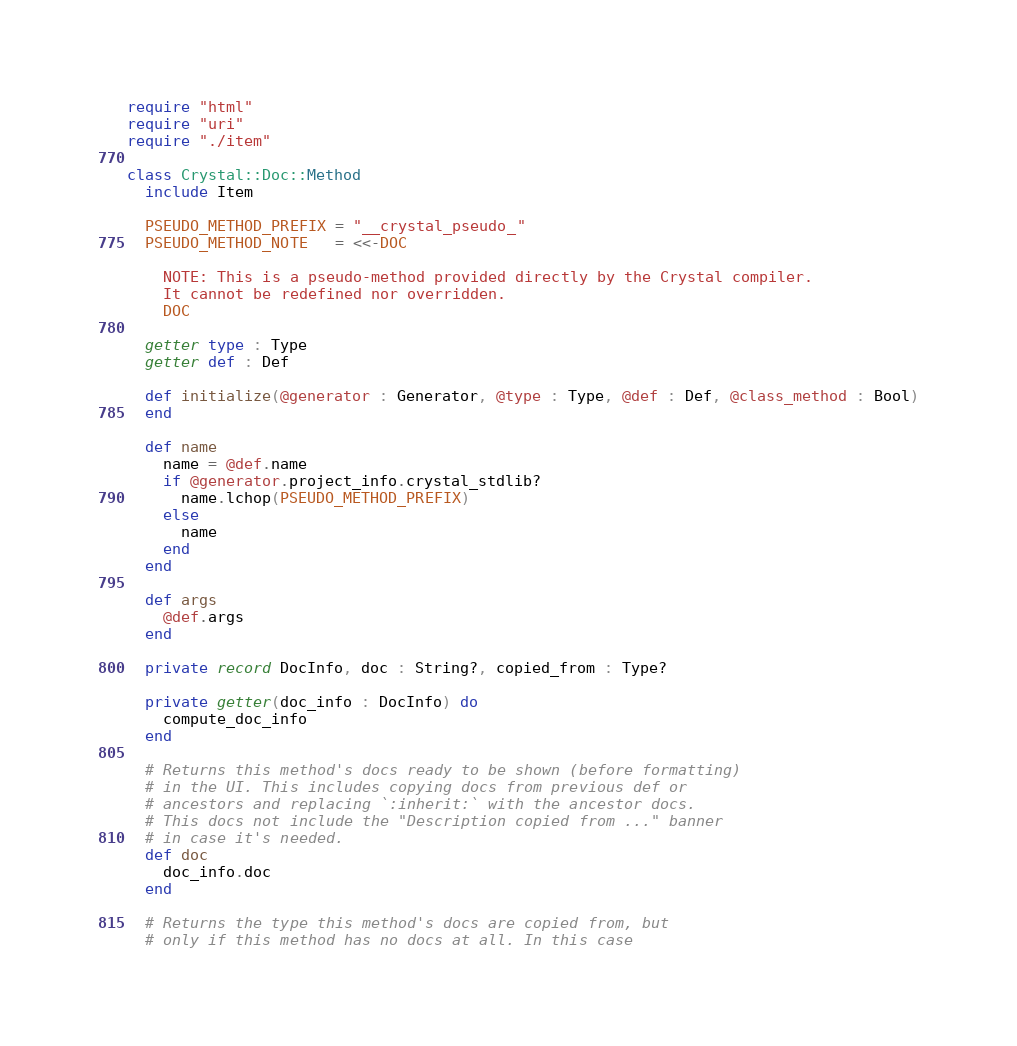<code> <loc_0><loc_0><loc_500><loc_500><_Crystal_>require "html"
require "uri"
require "./item"

class Crystal::Doc::Method
  include Item

  PSEUDO_METHOD_PREFIX = "__crystal_pseudo_"
  PSEUDO_METHOD_NOTE   = <<-DOC

    NOTE: This is a pseudo-method provided directly by the Crystal compiler.
    It cannot be redefined nor overridden.
    DOC

  getter type : Type
  getter def : Def

  def initialize(@generator : Generator, @type : Type, @def : Def, @class_method : Bool)
  end

  def name
    name = @def.name
    if @generator.project_info.crystal_stdlib?
      name.lchop(PSEUDO_METHOD_PREFIX)
    else
      name
    end
  end

  def args
    @def.args
  end

  private record DocInfo, doc : String?, copied_from : Type?

  private getter(doc_info : DocInfo) do
    compute_doc_info
  end

  # Returns this method's docs ready to be shown (before formatting)
  # in the UI. This includes copying docs from previous def or
  # ancestors and replacing `:inherit:` with the ancestor docs.
  # This docs not include the "Description copied from ..." banner
  # in case it's needed.
  def doc
    doc_info.doc
  end

  # Returns the type this method's docs are copied from, but
  # only if this method has no docs at all. In this case</code> 